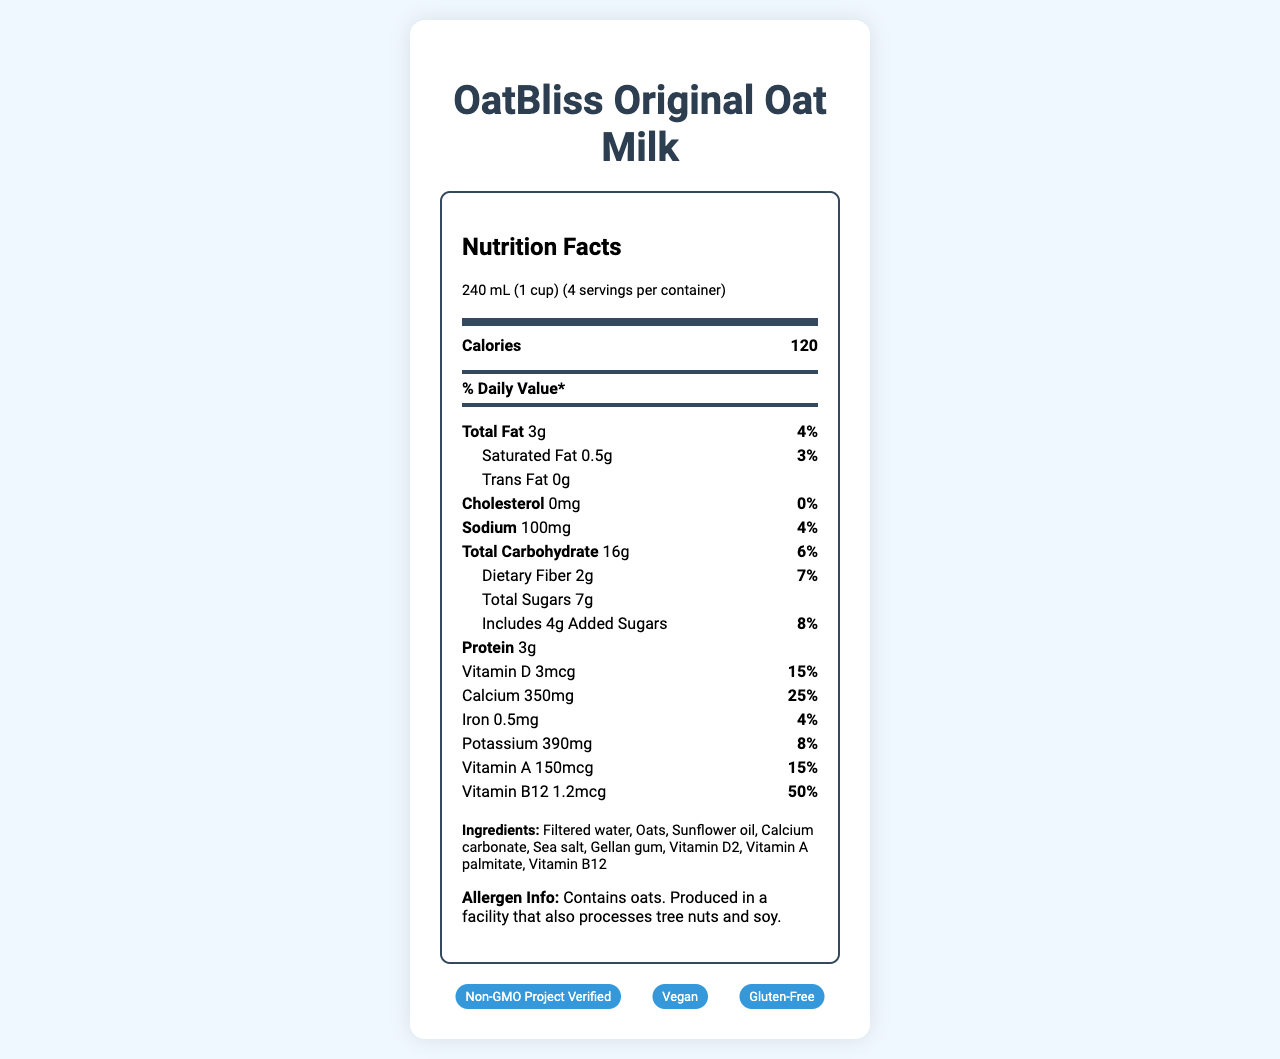what is the serving size? The serving size is listed at the beginning of the nutrition facts section as "240 mL (1 cup)".
Answer: 240 mL (1 cup) how many calories are in one serving? The number of calories per serving is listed as "120" in the nutrition facts section.
Answer: 120 what is the amount of protein per serving? The protein amount per serving is listed as "3g" in the nutrition facts section.
Answer: 3g list the nutrients that have daily value percentages. The nutrients with daily value percentages are shown with their corresponding percentages in the nutrition facts section.
Answer: Total Fat, Saturated Fat, Sodium, Total Carbohydrate, Dietary Fiber, Added Sugars, Vitamin D, Calcium, Iron, Potassium, Vitamin A, Vitamin B12 how many servings are there per container? The number of servings per container is listed as "4" in the serving information section near the top.
Answer: 4 which ingredient is listed first in the ingredients list? The first ingredient listed is "Filtered water".
Answer: Filtered water does the product contain any trans fat? The trans fat amount is listed as "0g", indicating there is no trans fat in the product.
Answer: No what percentage of the daily value of calcium does one serving provide? The daily value percentage for calcium per serving is listed as "25%" in the nutrition facts section.
Answer: 25% what certifications does this product have? A. Organic B. Vegan C. Non-GMO Project Verified D. Gluten-Free The certifications listed in the document are "Non-GMO Project Verified", "Vegan", and "Gluten-Free".
Answer: B, C, and D which vitamin has the highest daily value percentage per serving? A. Vitamin D B. Vitamin A C. Vitamin B12 The daily value percentage for Vitamin B12 is listed as 50%, which is higher than the percentages listed for Vitamin D (15%) and Vitamin A (15%).
Answer: C. Vitamin B12 does this product contain any allergens? The allergen information states "Contains oats. Produced in a facility that also processes tree nuts and soy."
Answer: Yes describe the main idea of the document. The document is centered around providing detailed nutritional information about OatBliss Original Oat Milk, including calories, fats, vitamins, minerals, and other nutrients, along with certification and allergen information.
Answer: The document provides the nutrition facts, ingredient list, allergen information, and certifications for OatBliss Original Oat Milk. It details the serving size, nutrient amounts, daily value percentages, and includes a visual representation of the nutrition information. how much potassium is in one serving? The amount of potassium per serving is listed as "390mg" in the nutrition facts section.
Answer: 390mg can the cholesterol content be determined from the document? The cholesterol content is listed as "0mg" in the nutrition facts section.
Answer: Yes how many grams of added sugars are there per serving? The added sugars amount per serving is listed as "4g" in the nutrition facts section.
Answer: 4g what is the daily value percentage of sodium for one serving? The daily value percentage for sodium per serving is listed as "4%" in the nutrition facts section.
Answer: 4% what is the overall purpose of the document? The document serves as a comprehensive guide to understanding the nutritional value, ingredients, potential allergens, and quality certifications of the product to assist consumers in making knowledgeable dietary decisions.
Answer: The document aims to provide detailed nutritional information, ingredients, allergen information, and certifications for the product OatBliss Original Oat Milk, helping consumers make informed choices. is this product certified organic? The document does not list "Organic" as one of the certifications. The certifications listed are "Non-GMO Project Verified", "Vegan", and "Gluten-Free".
Answer: No is there any information about fiber in the document? The document lists "Dietary Fiber" as 2g per serving with a daily value of 7% in the nutrition facts section.
Answer: Yes 